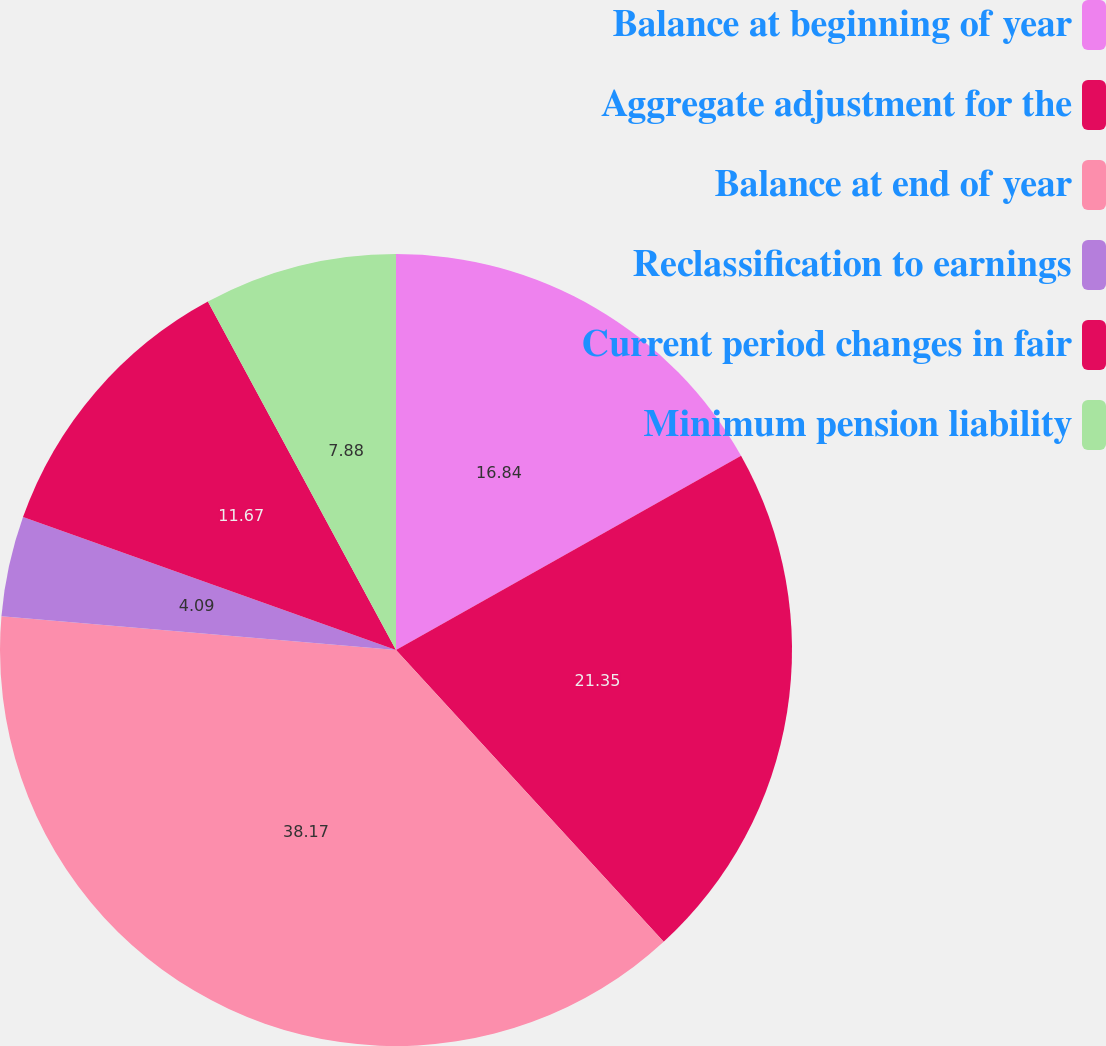Convert chart. <chart><loc_0><loc_0><loc_500><loc_500><pie_chart><fcel>Balance at beginning of year<fcel>Aggregate adjustment for the<fcel>Balance at end of year<fcel>Reclassification to earnings<fcel>Current period changes in fair<fcel>Minimum pension liability<nl><fcel>16.84%<fcel>21.35%<fcel>38.18%<fcel>4.09%<fcel>11.67%<fcel>7.88%<nl></chart> 